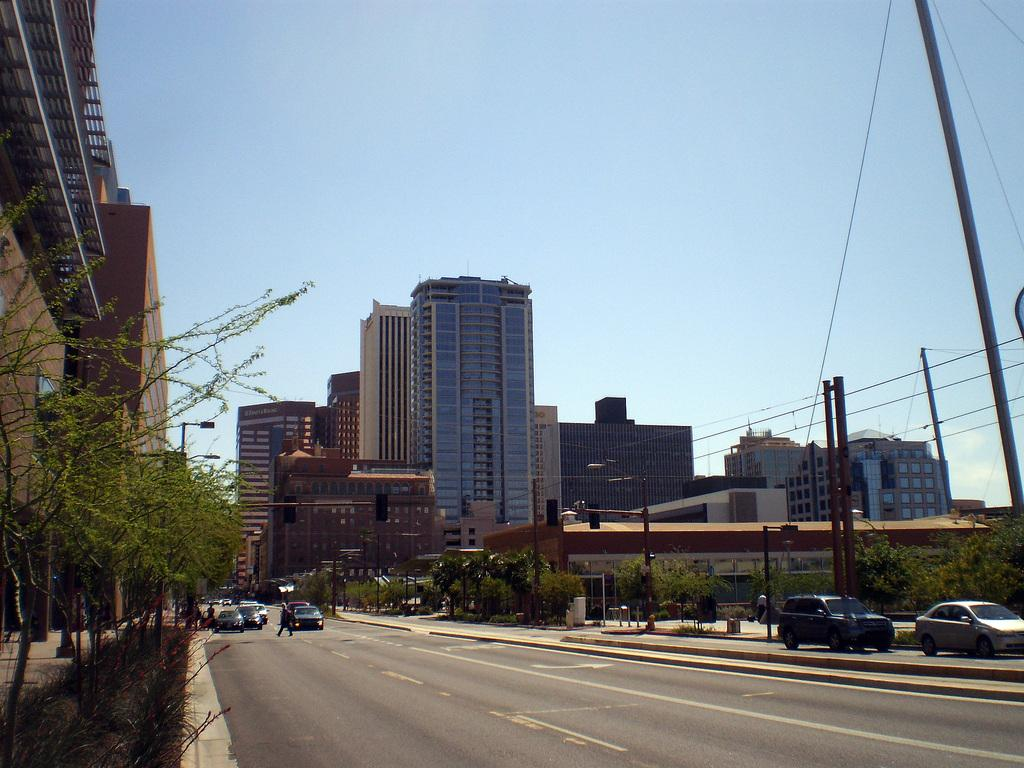What can be seen on the road in the image? There are vehicles on the road in the image. Who or what else is present in the image besides the vehicles? There is a group of people, trees, poles, cables, signal lights, and buildings in the image. What is visible in the background of the image? The sky is visible in the background of the image. What type of ant can be seen participating in the discussion in the image? There are no ants present in the image, and therefore no discussion involving ants can be observed. What is the view from the top of the tallest building in the image? The image does not provide a view from the top of any building, so it cannot be determined. 